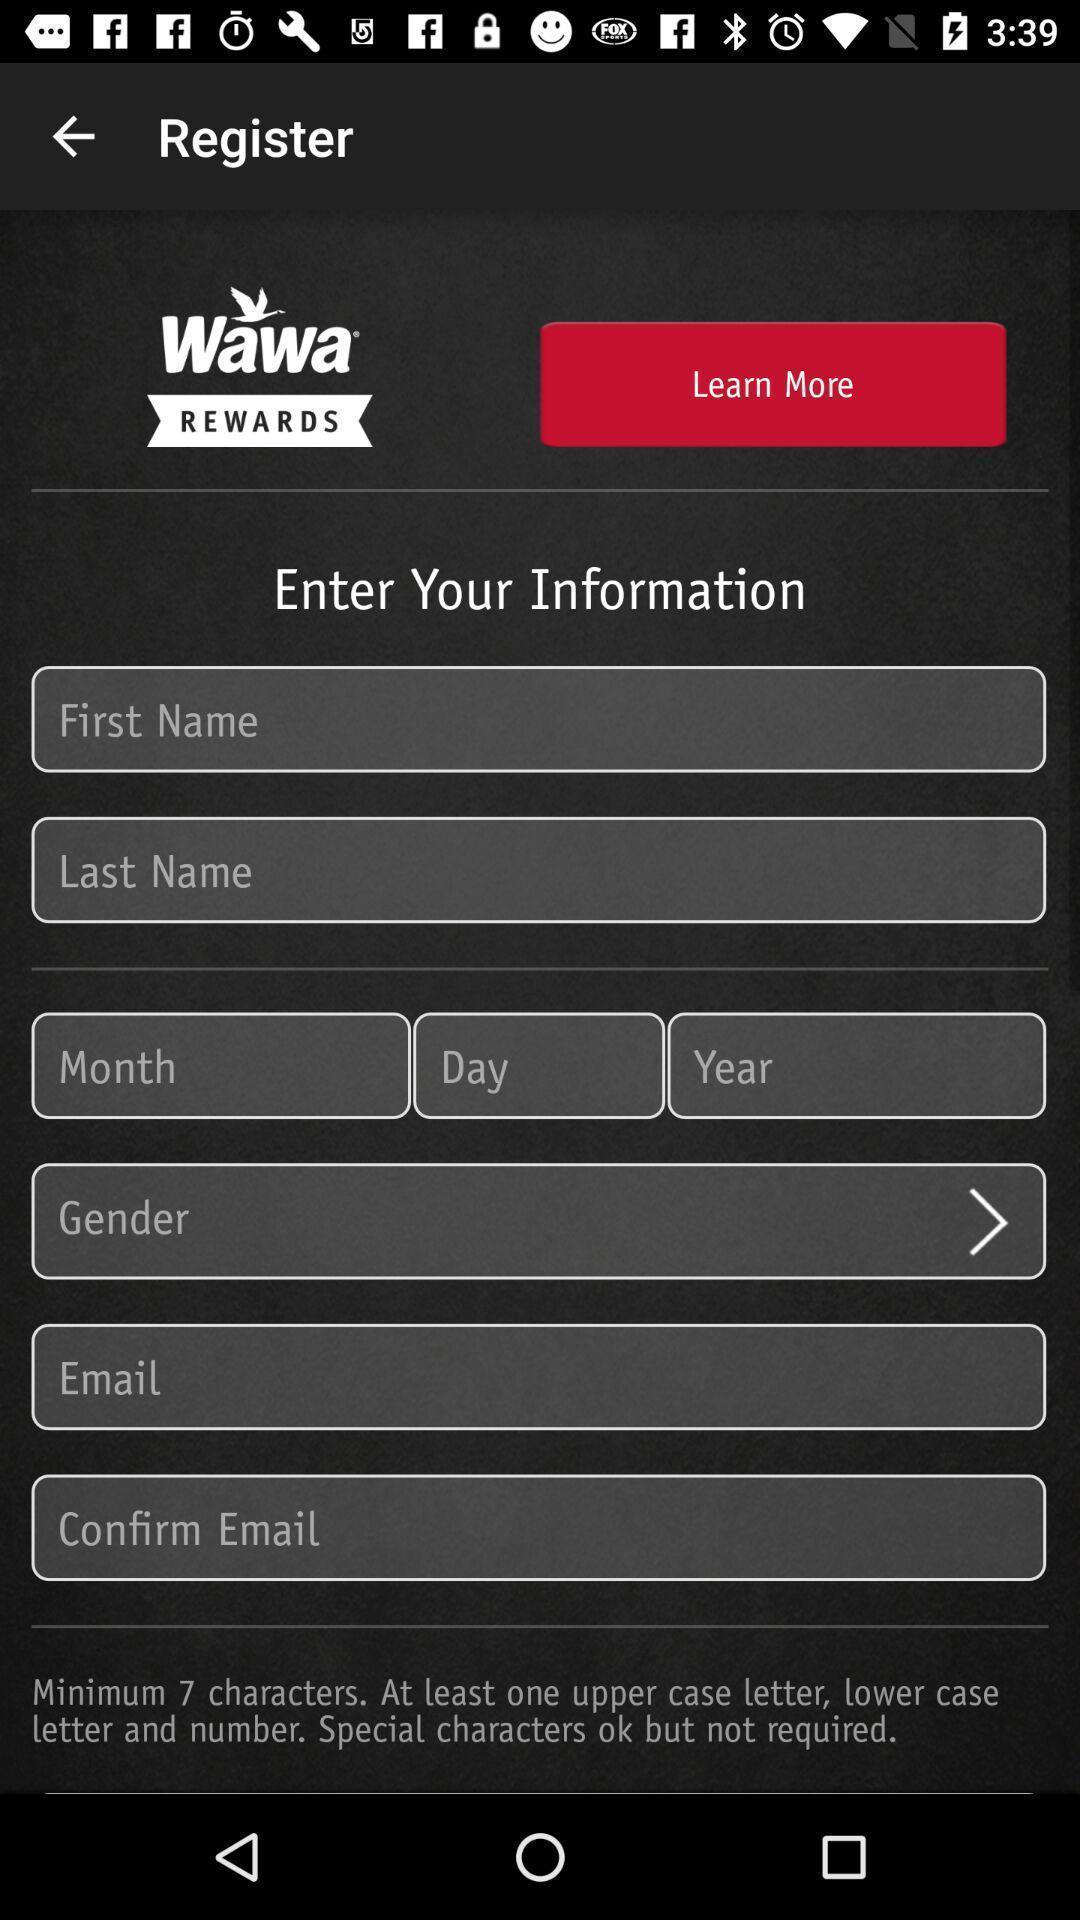What is the overall content of this screenshot? Register page. 